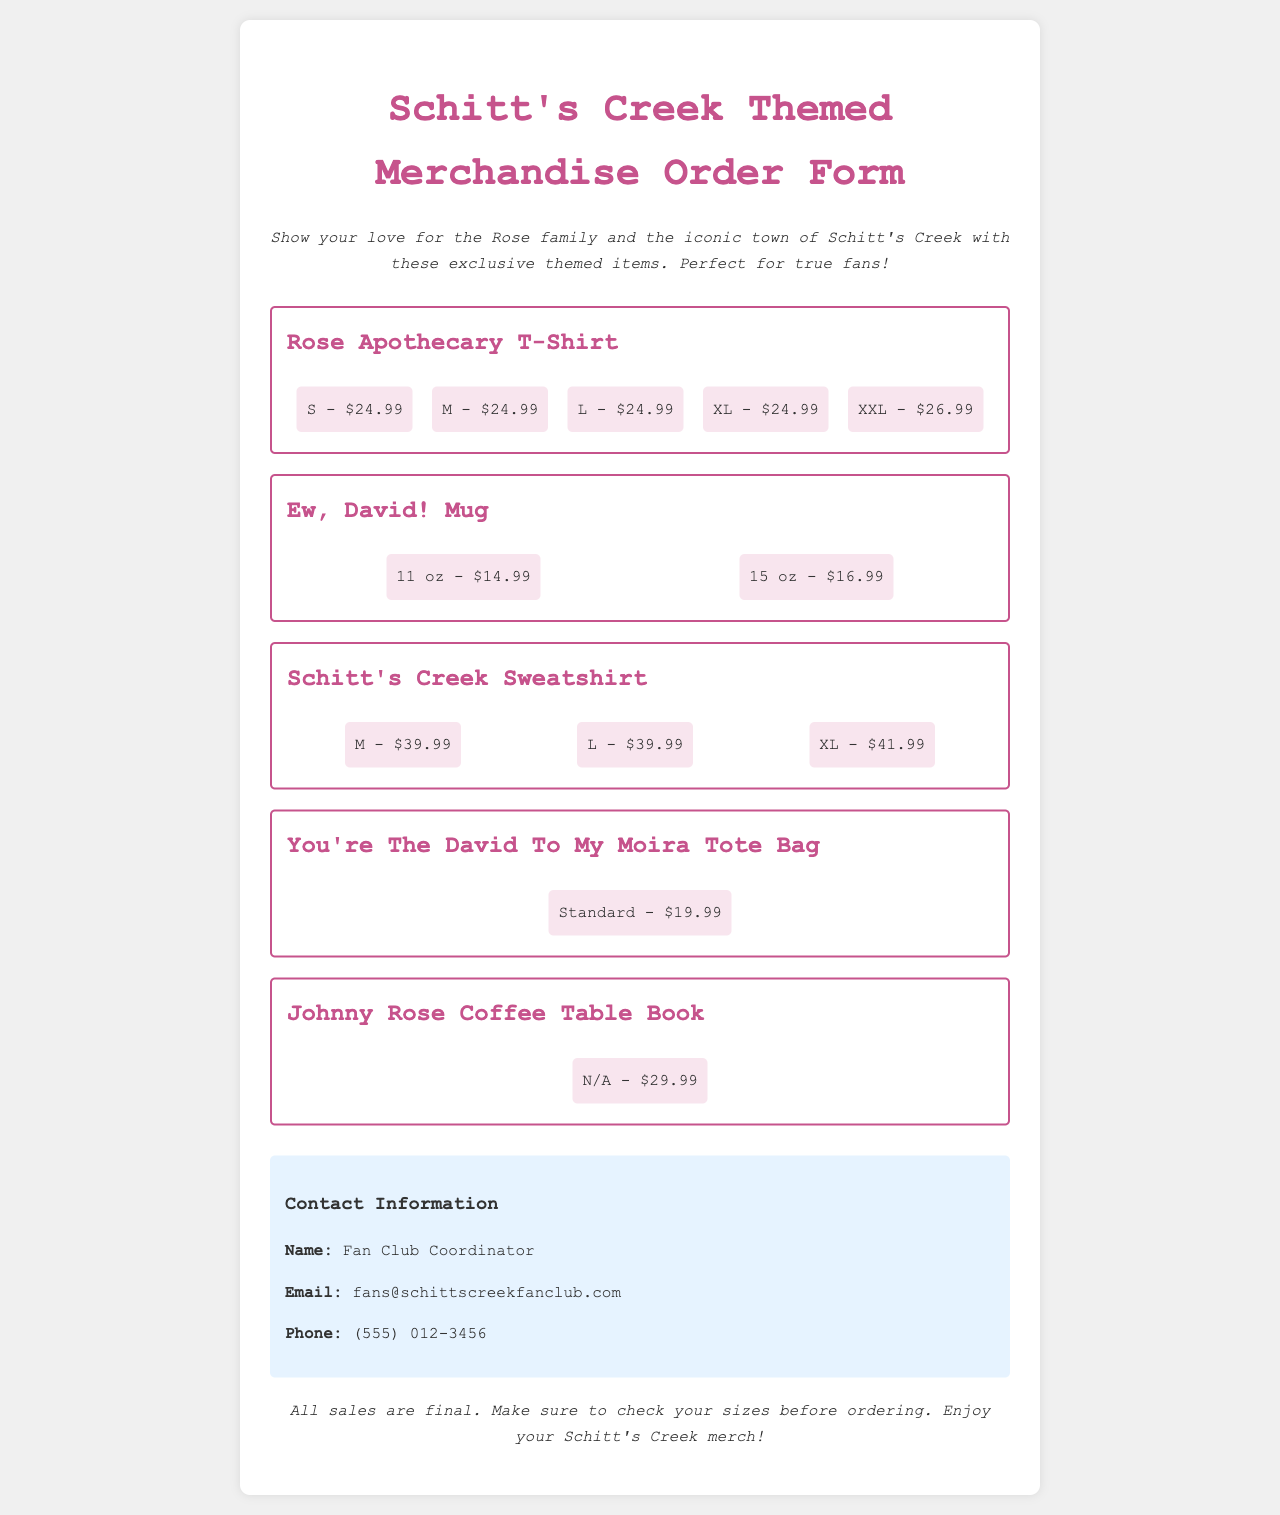What is the price of the Rose Apothecary T-Shirt in size M? The price for the Rose Apothecary T-Shirt in size M is stated in the document.
Answer: $24.99 What is the price of the Ew, David! Mug in 15 oz? The price for the Ew, David! Mug in the 15 oz size is provided in the document.
Answer: $16.99 Which item has a price of $39.99? This question requires looking for items in the document with the specified price.
Answer: Schitt's Creek Sweatshirt What size is available for the You're The David To My Moira Tote Bag? The available sizes for the tote bag are listed in the document.
Answer: Standard Who is the contact person for the merchandise order form? The document provides the name of the person to contact for information about the order form.
Answer: Fan Club Coordinator What is the price of Johnny Rose Coffee Table Book? The document includes information about the Johnny Rose Coffee Table Book and its price.
Answer: $29.99 How many sizes are available for the Schitt's Creek Sweatshirt? This question requires counting the number of sizes mentioned in the document for the specified item.
Answer: 3 Is all sales final according to the document? The document includes an important note regarding sales and their finality.
Answer: Yes 